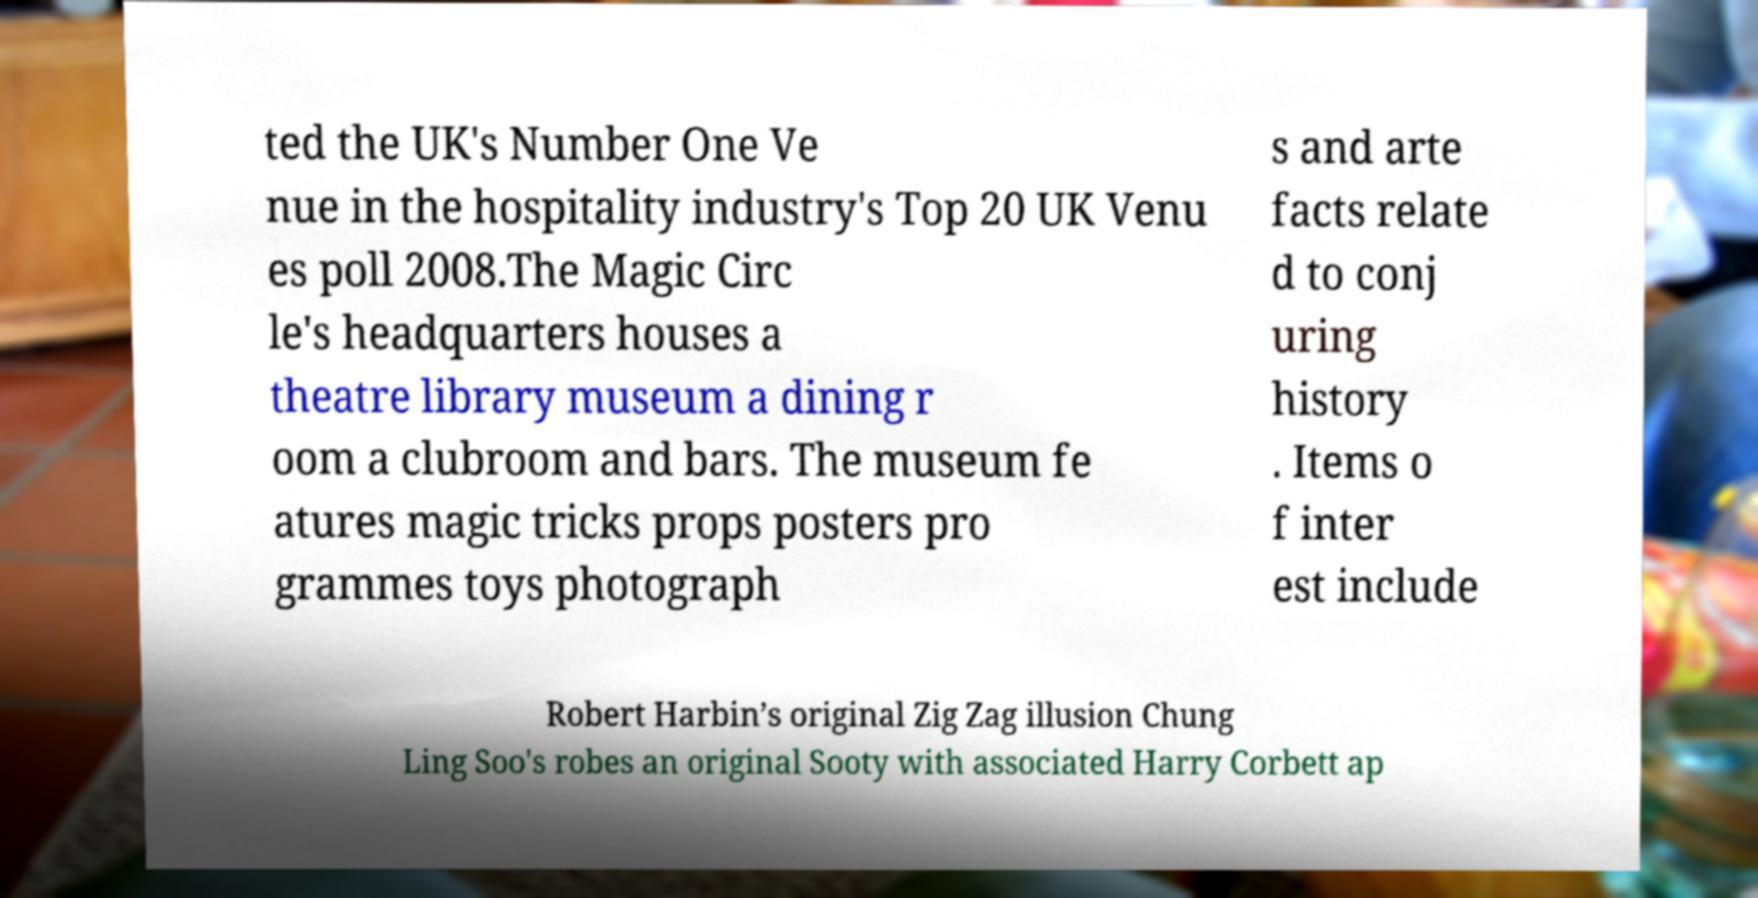Can you accurately transcribe the text from the provided image for me? ted the UK's Number One Ve nue in the hospitality industry's Top 20 UK Venu es poll 2008.The Magic Circ le's headquarters houses a theatre library museum a dining r oom a clubroom and bars. The museum fe atures magic tricks props posters pro grammes toys photograph s and arte facts relate d to conj uring history . Items o f inter est include Robert Harbin’s original Zig Zag illusion Chung Ling Soo's robes an original Sooty with associated Harry Corbett ap 